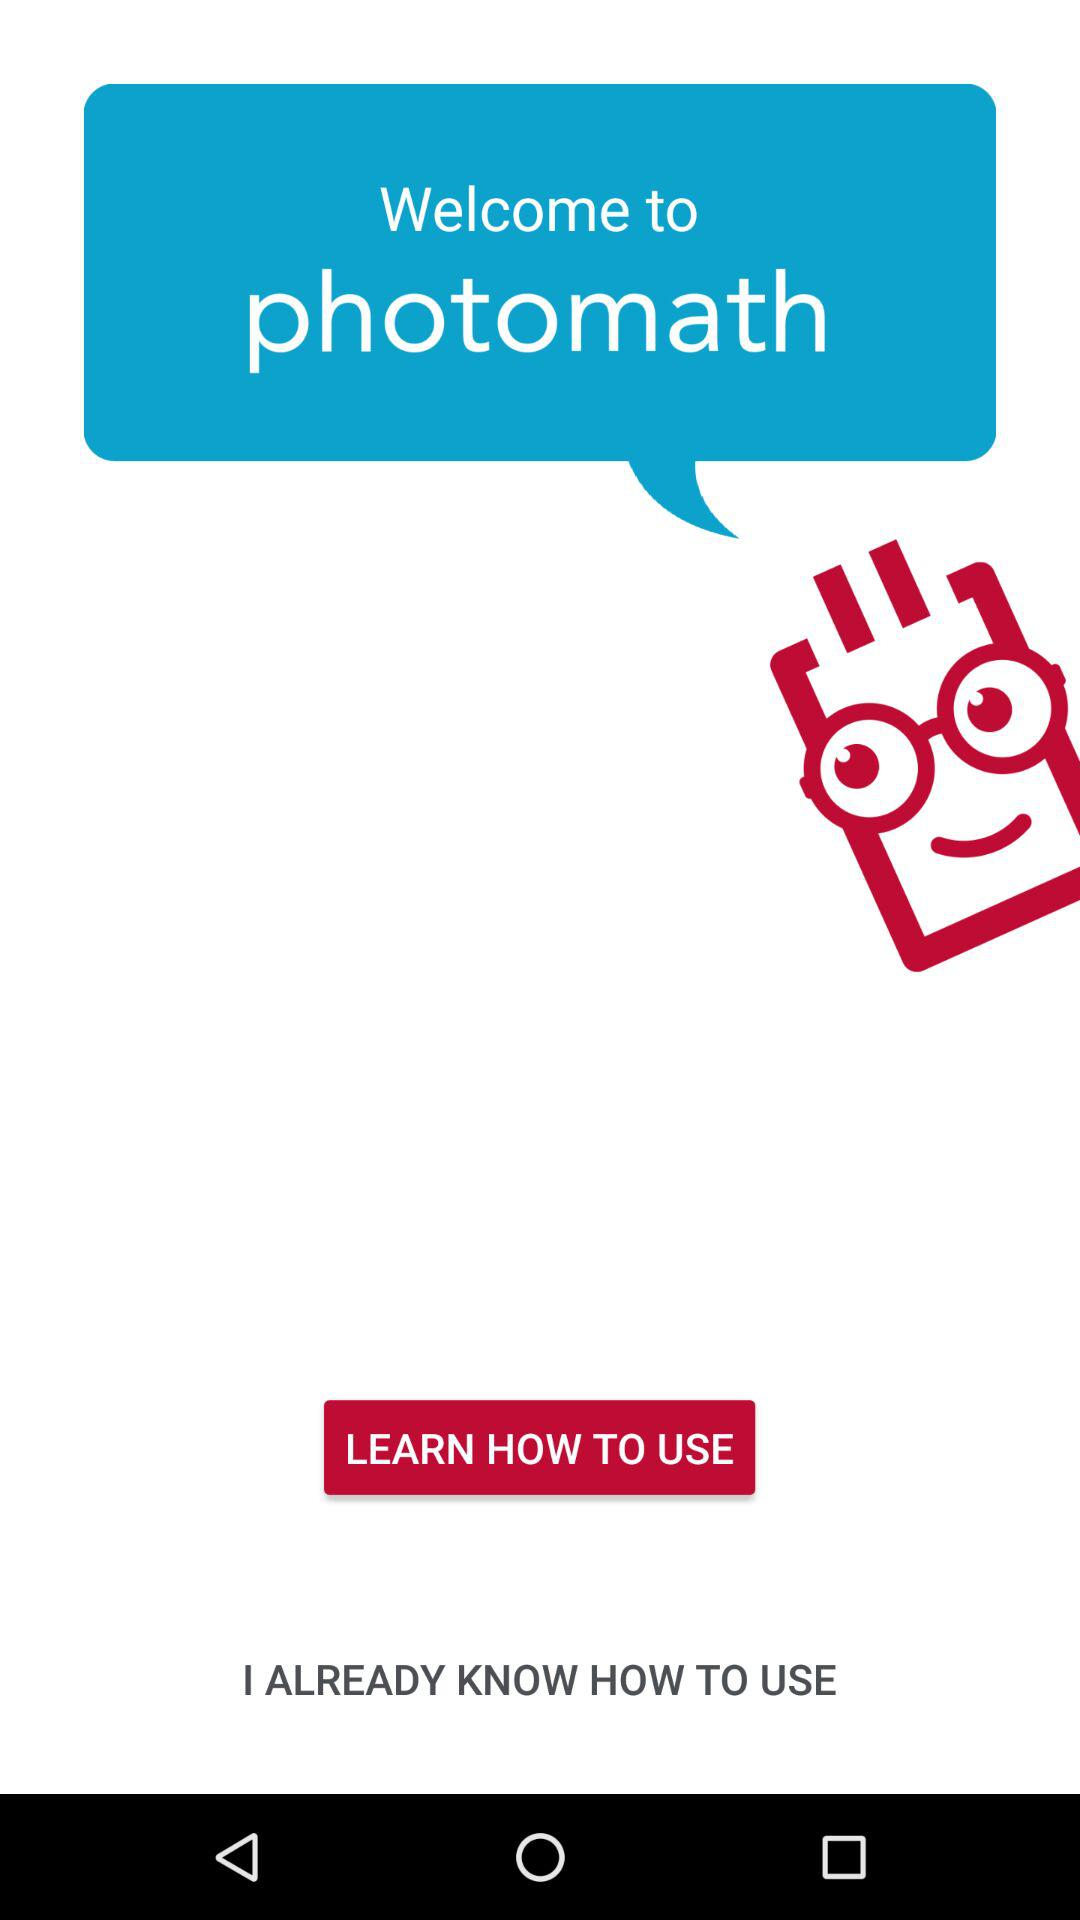What is the name of the application? The name of the application is "photomath". 